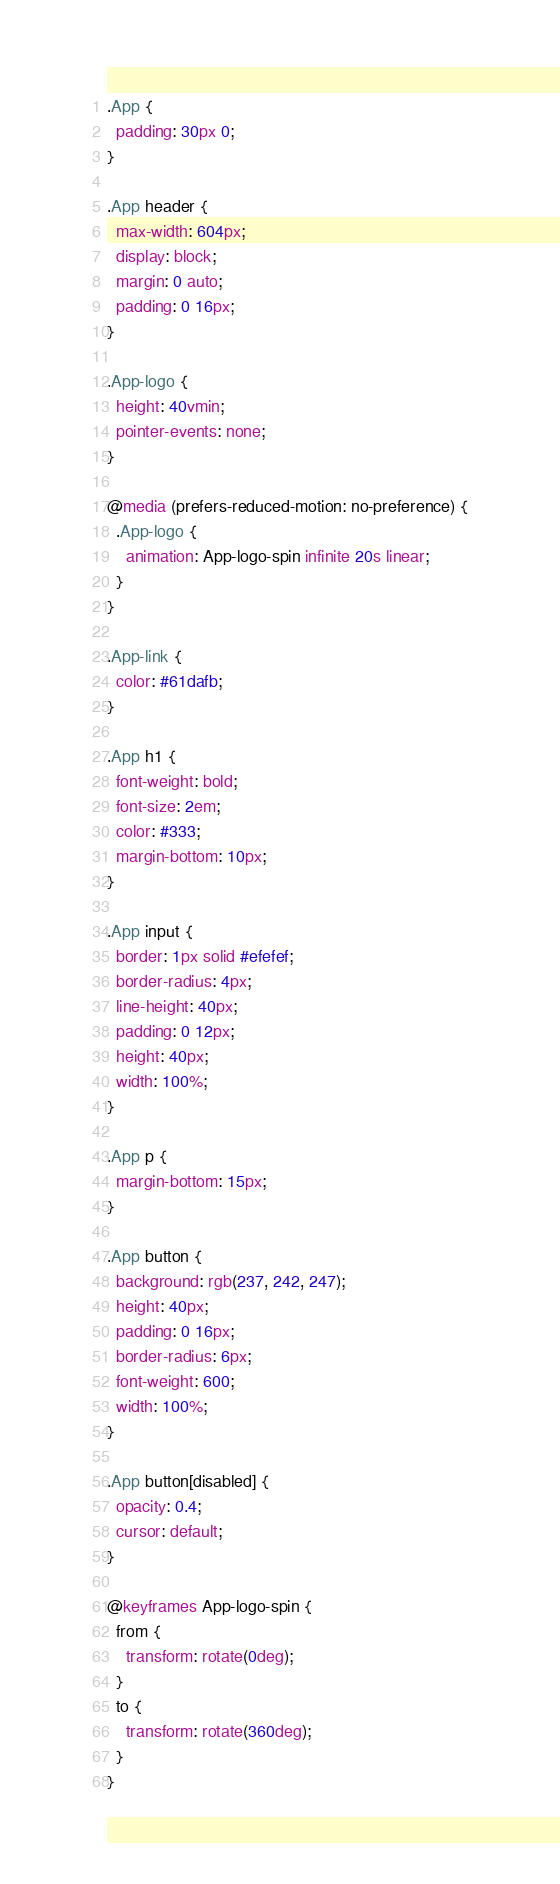<code> <loc_0><loc_0><loc_500><loc_500><_CSS_>.App {
  padding: 30px 0;
}

.App header {
  max-width: 604px;
  display: block;
  margin: 0 auto;
  padding: 0 16px;
}

.App-logo {
  height: 40vmin;
  pointer-events: none;
}

@media (prefers-reduced-motion: no-preference) {
  .App-logo {
    animation: App-logo-spin infinite 20s linear;
  }
}

.App-link {
  color: #61dafb;
}

.App h1 {
  font-weight: bold;
  font-size: 2em;
  color: #333;
  margin-bottom: 10px;
}

.App input {
  border: 1px solid #efefef;
  border-radius: 4px;
  line-height: 40px;
  padding: 0 12px;
  height: 40px;
  width: 100%;
}

.App p {
  margin-bottom: 15px;
}

.App button {
  background: rgb(237, 242, 247);
  height: 40px;
  padding: 0 16px;
  border-radius: 6px;
  font-weight: 600;
  width: 100%;
}

.App button[disabled] {
  opacity: 0.4;
  cursor: default;
}

@keyframes App-logo-spin {
  from {
    transform: rotate(0deg);
  }
  to {
    transform: rotate(360deg);
  }
}
</code> 